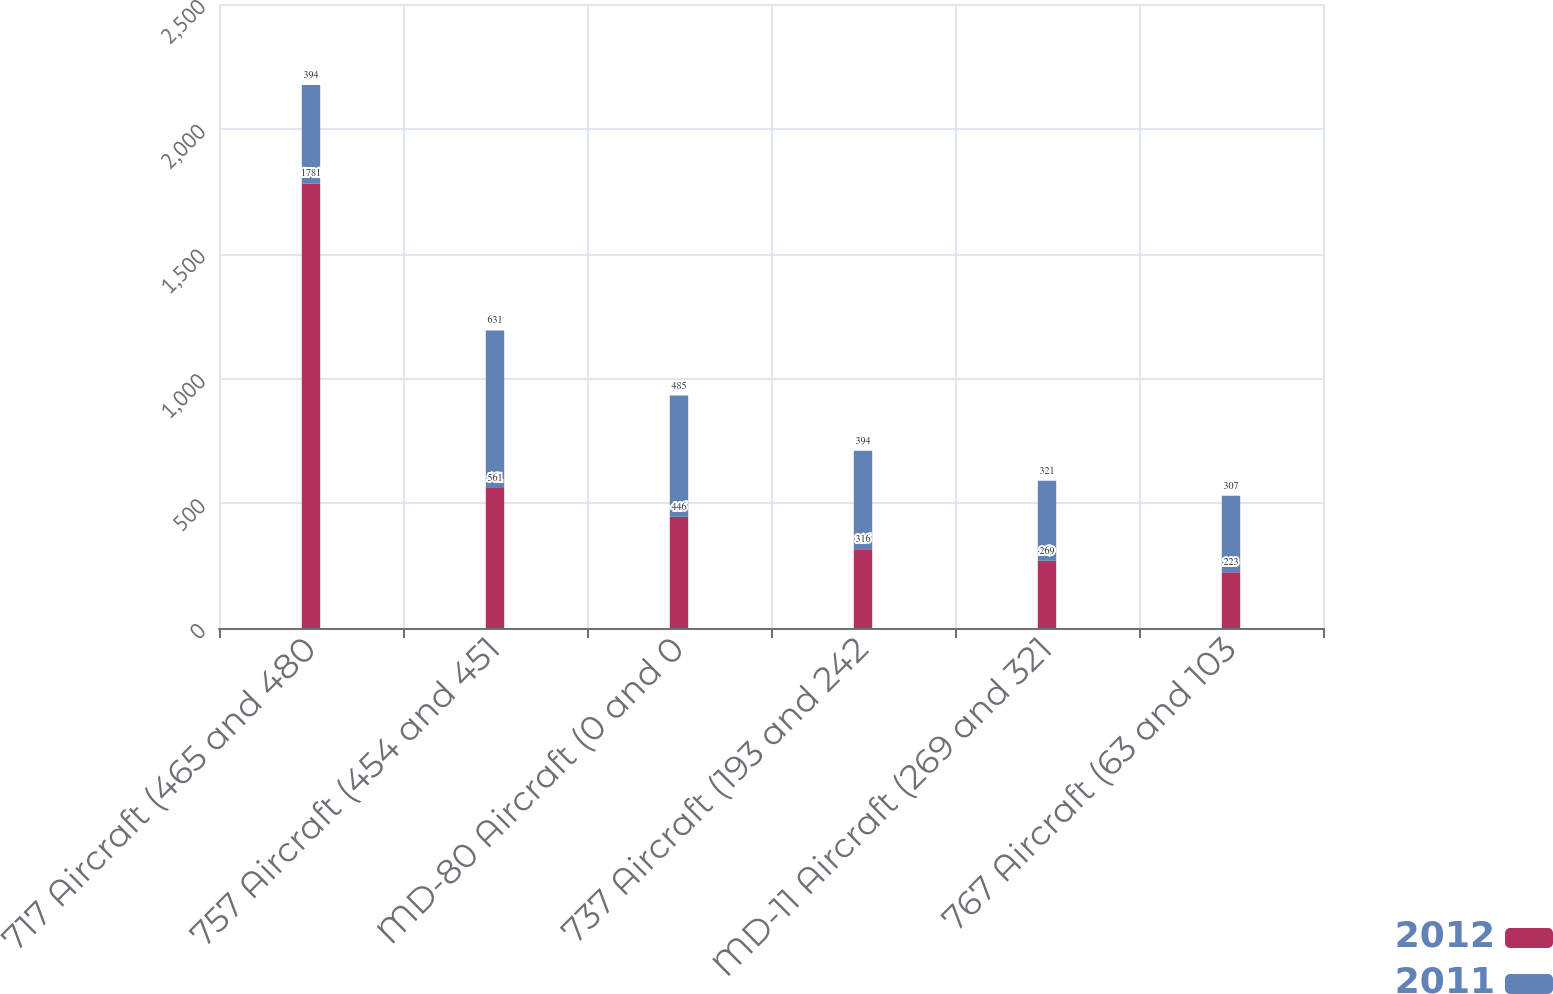Convert chart to OTSL. <chart><loc_0><loc_0><loc_500><loc_500><stacked_bar_chart><ecel><fcel>717 Aircraft (465 and 480<fcel>757 Aircraft (454 and 451<fcel>MD-80 Aircraft (0 and 0<fcel>737 Aircraft (193 and 242<fcel>MD-11 Aircraft (269 and 321<fcel>767 Aircraft (63 and 103<nl><fcel>2012<fcel>1781<fcel>561<fcel>446<fcel>316<fcel>269<fcel>223<nl><fcel>2011<fcel>394<fcel>631<fcel>485<fcel>394<fcel>321<fcel>307<nl></chart> 